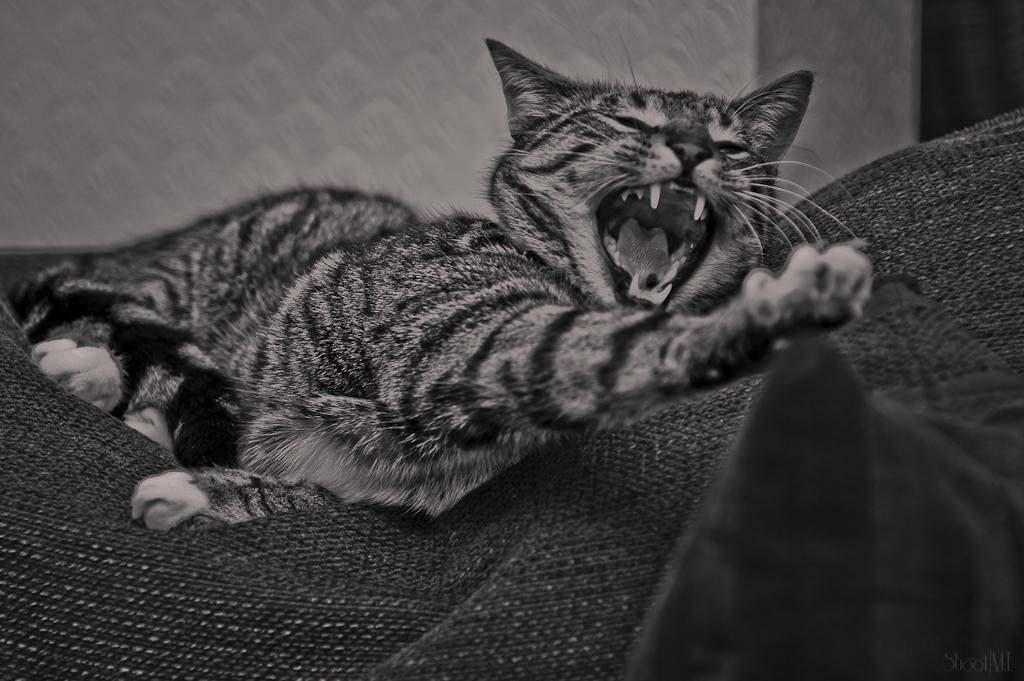What is the color scheme of the image? The image is black and white. What is the main subject in the center of the image? There is a cat in the center of the image. What is located at the bottom of the image? There is a cloth at the bottom of the image. What color is the wall at the top of the image? The wall at the top of the image is painted white. What type of berry can be seen in the image? There is no berry present in the image. How does the cat waste time in the image? The image does not depict the cat's actions or activities, so it is impossible to determine how the cat might waste time. 